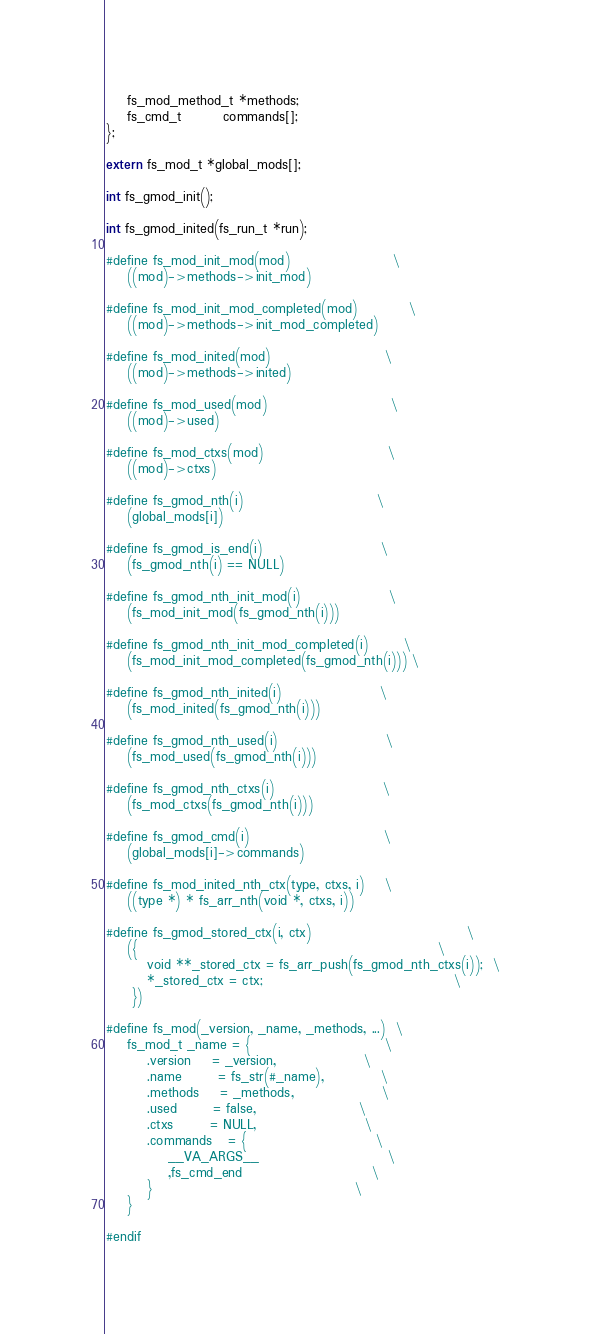<code> <loc_0><loc_0><loc_500><loc_500><_C_>
    fs_mod_method_t *methods;
    fs_cmd_t        commands[];
};

extern fs_mod_t *global_mods[];

int fs_gmod_init();

int fs_gmod_inited(fs_run_t *run);

#define fs_mod_init_mod(mod)                    \
    ((mod)->methods->init_mod)

#define fs_mod_init_mod_completed(mod)          \
    ((mod)->methods->init_mod_completed)

#define fs_mod_inited(mod)                      \
    ((mod)->methods->inited)

#define fs_mod_used(mod)                        \
    ((mod)->used)

#define fs_mod_ctxs(mod)                        \
    ((mod)->ctxs)

#define fs_gmod_nth(i)                          \
    (global_mods[i])

#define fs_gmod_is_end(i)                       \
    (fs_gmod_nth(i) == NULL)

#define fs_gmod_nth_init_mod(i)                 \
    (fs_mod_init_mod(fs_gmod_nth(i)))

#define fs_gmod_nth_init_mod_completed(i)       \
    (fs_mod_init_mod_completed(fs_gmod_nth(i))) \

#define fs_gmod_nth_inited(i)                   \
    (fs_mod_inited(fs_gmod_nth(i)))

#define fs_gmod_nth_used(i)                     \
    (fs_mod_used(fs_gmod_nth(i)))

#define fs_gmod_nth_ctxs(i)                     \
    (fs_mod_ctxs(fs_gmod_nth(i)))

#define fs_gmod_cmd(i)                          \
    (global_mods[i]->commands)

#define fs_mod_inited_nth_ctx(type, ctxs, i)    \
    ((type *) * fs_arr_nth(void *, ctxs, i))

#define fs_gmod_stored_ctx(i, ctx)                              \
    ({                                                          \
        void **_stored_ctx = fs_arr_push(fs_gmod_nth_ctxs(i));  \
        *_stored_ctx = ctx;                                     \
     })

#define fs_mod(_version, _name, _methods, ...)  \
    fs_mod_t _name = {                          \
        .version    = _version,                 \
        .name       = fs_str(#_name),           \
        .methods    = _methods,                 \
        .used       = false,                    \
        .ctxs       = NULL,                     \
        .commands   = {                         \
            __VA_ARGS__                         \
            ,fs_cmd_end                         \
        }                                       \
    }

#endif
</code> 